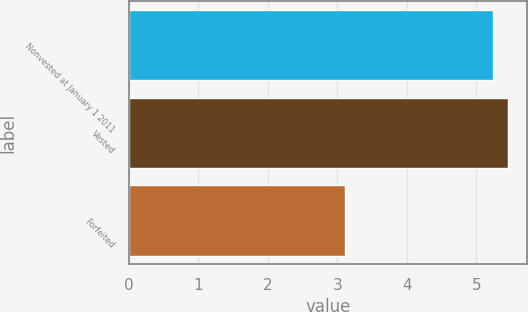<chart> <loc_0><loc_0><loc_500><loc_500><bar_chart><fcel>Nonvested at January 1 2011<fcel>Vested<fcel>Forfeited<nl><fcel>5.24<fcel>5.46<fcel>3.11<nl></chart> 